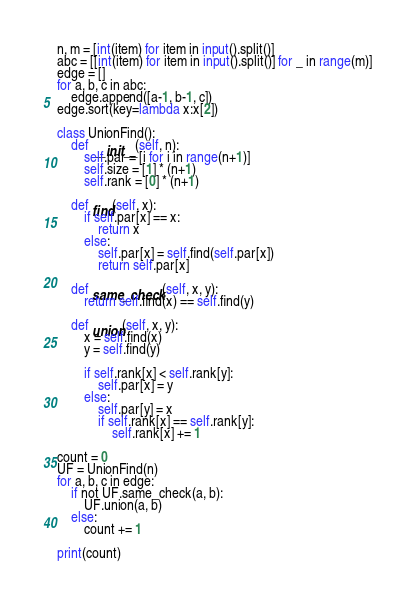<code> <loc_0><loc_0><loc_500><loc_500><_Python_>n, m = [int(item) for item in input().split()]
abc = [[int(item) for item in input().split()] for _ in range(m)]
edge = []
for a, b, c in abc:
    edge.append([a-1, b-1, c])
edge.sort(key=lambda x:x[2])

class UnionFind():
    def __init__(self, n):
        self.par = [i for i in range(n+1)]
        self.size = [1] * (n+1)
        self.rank = [0] * (n+1)
    
    def find(self, x):
        if self.par[x] == x:
            return x
        else:
            self.par[x] = self.find(self.par[x])
            return self.par[x]

    def same_check(self, x, y):
        return self.find(x) == self.find(y)

    def union(self, x, y):
        x = self.find(x)
        y = self.find(y)

        if self.rank[x] < self.rank[y]:
            self.par[x] = y
        else:
            self.par[y] = x
            if self.rank[x] == self.rank[y]:
                self.rank[x] += 1

count = 0
UF = UnionFind(n)
for a, b, c in edge:
    if not UF.same_check(a, b):
        UF.union(a, b)
    else:
        count += 1

print(count)</code> 